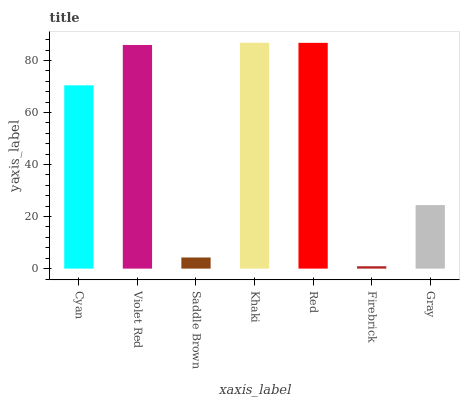Is Firebrick the minimum?
Answer yes or no. Yes. Is Khaki the maximum?
Answer yes or no. Yes. Is Violet Red the minimum?
Answer yes or no. No. Is Violet Red the maximum?
Answer yes or no. No. Is Violet Red greater than Cyan?
Answer yes or no. Yes. Is Cyan less than Violet Red?
Answer yes or no. Yes. Is Cyan greater than Violet Red?
Answer yes or no. No. Is Violet Red less than Cyan?
Answer yes or no. No. Is Cyan the high median?
Answer yes or no. Yes. Is Cyan the low median?
Answer yes or no. Yes. Is Khaki the high median?
Answer yes or no. No. Is Red the low median?
Answer yes or no. No. 